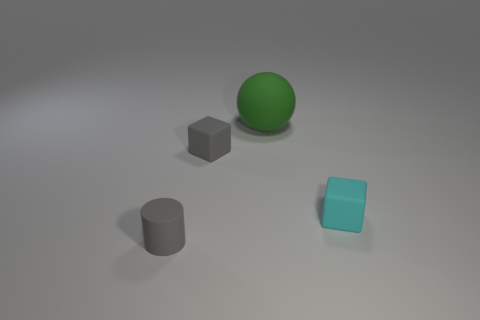Are there more green objects than yellow rubber balls?
Offer a very short reply. Yes. Is there anything else of the same color as the rubber ball?
Ensure brevity in your answer.  No. There is a green thing that is the same material as the tiny cylinder; what is its size?
Provide a succinct answer. Large. What material is the gray cylinder?
Give a very brief answer. Rubber. What number of gray matte objects have the same size as the gray matte cylinder?
Make the answer very short. 1. What is the shape of the thing that is the same color as the cylinder?
Keep it short and to the point. Cube. Are there any large cyan shiny things of the same shape as the large green object?
Your answer should be compact. No. There is a block that is the same size as the cyan object; what color is it?
Offer a very short reply. Gray. What color is the small object right of the block that is behind the tiny cyan thing?
Keep it short and to the point. Cyan. There is a small block that is left of the big thing; does it have the same color as the cylinder?
Make the answer very short. Yes. 